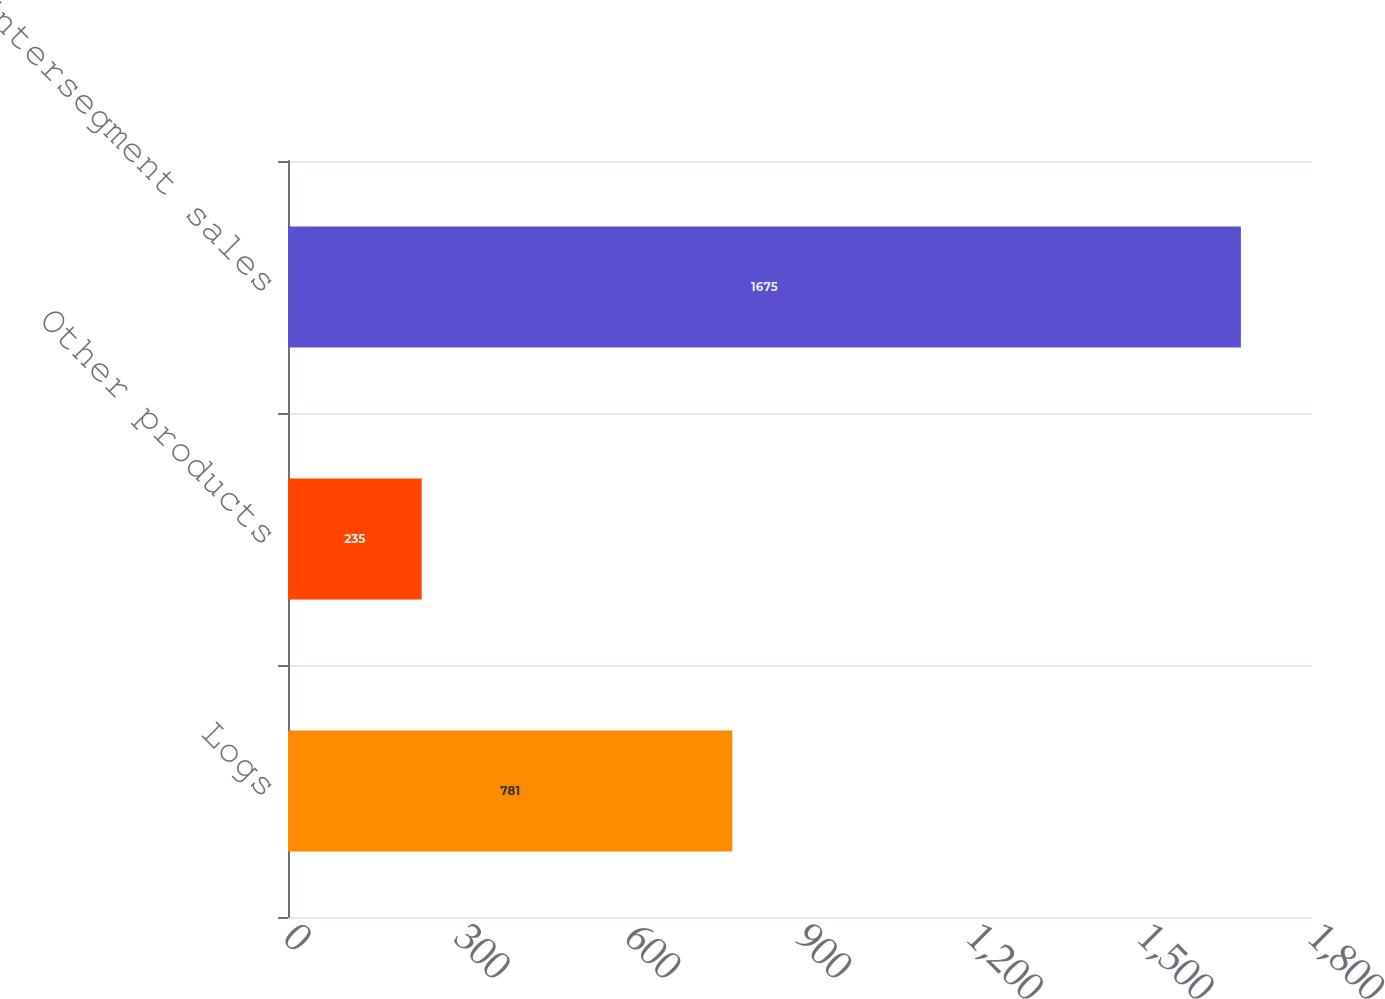Convert chart to OTSL. <chart><loc_0><loc_0><loc_500><loc_500><bar_chart><fcel>Logs<fcel>Other products<fcel>Intersegment sales<nl><fcel>781<fcel>235<fcel>1675<nl></chart> 